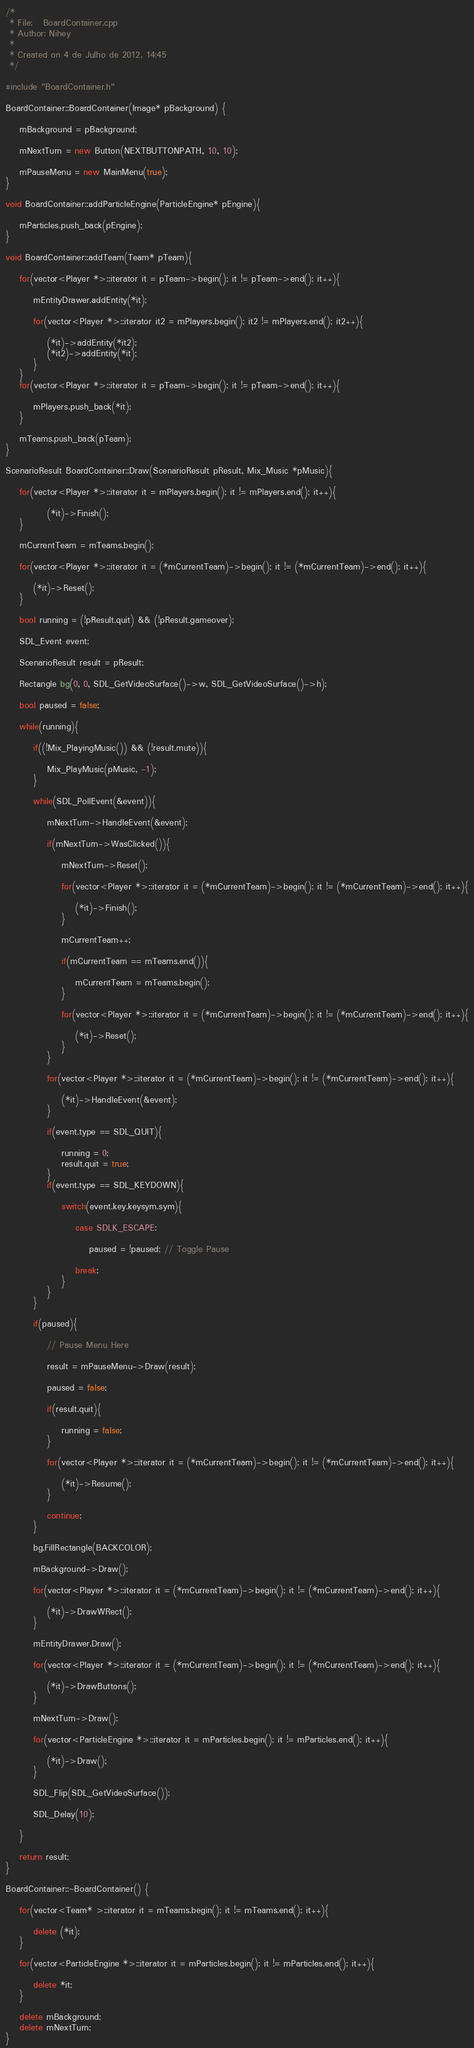Convert code to text. <code><loc_0><loc_0><loc_500><loc_500><_C++_>/* 
 * File:   BoardContainer.cpp
 * Author: Nihey
 * 
 * Created on 4 de Julho de 2012, 14:45
 */

#include "BoardContainer.h"

BoardContainer::BoardContainer(Image* pBackground) {
    
    mBackground = pBackground;
    
    mNextTurn = new Button(NEXTBUTTONPATH, 10, 10);
    
    mPauseMenu = new MainMenu(true);
}

void BoardContainer::addParticleEngine(ParticleEngine* pEngine){
    
    mParticles.push_back(pEngine);
}

void BoardContainer::addTeam(Team* pTeam){
    
    for(vector<Player *>::iterator it = pTeam->begin(); it != pTeam->end(); it++){
        
        mEntityDrawer.addEntity(*it);
        
        for(vector<Player *>::iterator it2 = mPlayers.begin(); it2 != mPlayers.end(); it2++){
            
            (*it)->addEntity(*it2);
            (*it2)->addEntity(*it);
        }
    }
    for(vector<Player *>::iterator it = pTeam->begin(); it != pTeam->end(); it++){
        
        mPlayers.push_back(*it);
    }
    
    mTeams.push_back(pTeam);
}

ScenarioResult BoardContainer::Draw(ScenarioResult pResult, Mix_Music *pMusic){
    
    for(vector<Player *>::iterator it = mPlayers.begin(); it != mPlayers.end(); it++){
            
            (*it)->Finish();
    }
    
    mCurrentTeam = mTeams.begin();
    
    for(vector<Player *>::iterator it = (*mCurrentTeam)->begin(); it != (*mCurrentTeam)->end(); it++){
                
        (*it)->Reset();
    }
    
    bool running = (!pResult.quit) && (!pResult.gameover);
    
    SDL_Event event;
    
    ScenarioResult result = pResult;
    
    Rectangle bg(0, 0, SDL_GetVideoSurface()->w, SDL_GetVideoSurface()->h);
    
    bool paused = false;
    
    while(running){
        
        if((!Mix_PlayingMusic()) && (!result.mute)){
            
            Mix_PlayMusic(pMusic, -1);
        }
        
        while(SDL_PollEvent(&event)){
            
            mNextTurn->HandleEvent(&event);
            
            if(mNextTurn->WasClicked()){
                
                mNextTurn->Reset();
                
                for(vector<Player *>::iterator it = (*mCurrentTeam)->begin(); it != (*mCurrentTeam)->end(); it++){
                
                    (*it)->Finish();
                }
                
                mCurrentTeam++;
                
                if(mCurrentTeam == mTeams.end()){
                    
                    mCurrentTeam = mTeams.begin();
                }
                
                for(vector<Player *>::iterator it = (*mCurrentTeam)->begin(); it != (*mCurrentTeam)->end(); it++){
                
                    (*it)->Reset();
                }
            }
            
            for(vector<Player *>::iterator it = (*mCurrentTeam)->begin(); it != (*mCurrentTeam)->end(); it++){
                
                (*it)->HandleEvent(&event);
            }
            
            if(event.type == SDL_QUIT){
                
                running = 0;
                result.quit = true;
            }
            if(event.type == SDL_KEYDOWN){
                
                switch(event.key.keysym.sym){
                    
                    case SDLK_ESCAPE:
                    
                        paused = !paused; // Toggle Pause
                        
                    break;
                }
            }
        }
        
        if(paused){
            
            // Pause Menu Here
            
            result = mPauseMenu->Draw(result);
            
            paused = false;
            
            if(result.quit){
                
                running = false;
            }
            
            for(vector<Player *>::iterator it = (*mCurrentTeam)->begin(); it != (*mCurrentTeam)->end(); it++){
                
                (*it)->Resume();
            }
            
            continue;
        }
        
        bg.FillRectangle(BACKCOLOR);
        
        mBackground->Draw();
        
        for(vector<Player *>::iterator it = (*mCurrentTeam)->begin(); it != (*mCurrentTeam)->end(); it++){
                
            (*it)->DrawWRect();
        }
        
        mEntityDrawer.Draw();
        
        for(vector<Player *>::iterator it = (*mCurrentTeam)->begin(); it != (*mCurrentTeam)->end(); it++){
                
            (*it)->DrawButtons();
        }
        
        mNextTurn->Draw();
        
        for(vector<ParticleEngine *>::iterator it = mParticles.begin(); it != mParticles.end(); it++){
                
            (*it)->Draw();
        }
        
        SDL_Flip(SDL_GetVideoSurface());
        
        SDL_Delay(10);
        
    }   
    
    return result;
}

BoardContainer::~BoardContainer() {
    
    for(vector<Team* >::iterator it = mTeams.begin(); it != mTeams.end(); it++){
        
        delete (*it);
    }
    
    for(vector<ParticleEngine *>::iterator it = mParticles.begin(); it != mParticles.end(); it++){
                
        delete *it;
    }
    
    delete mBackground;
    delete mNextTurn;
}

</code> 